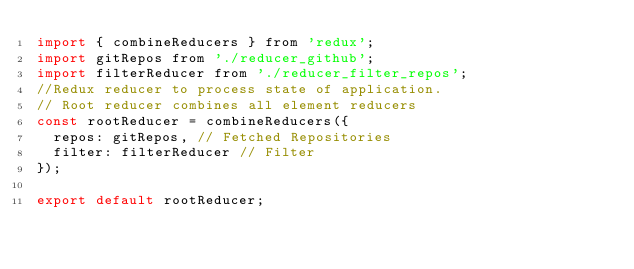Convert code to text. <code><loc_0><loc_0><loc_500><loc_500><_JavaScript_>import { combineReducers } from 'redux';
import gitRepos from './reducer_github';
import filterReducer from './reducer_filter_repos';
//Redux reducer to process state of application.
// Root reducer combines all element reducers
const rootReducer = combineReducers({
  repos: gitRepos, // Fetched Repositories
  filter: filterReducer // Filter 
});

export default rootReducer;
</code> 